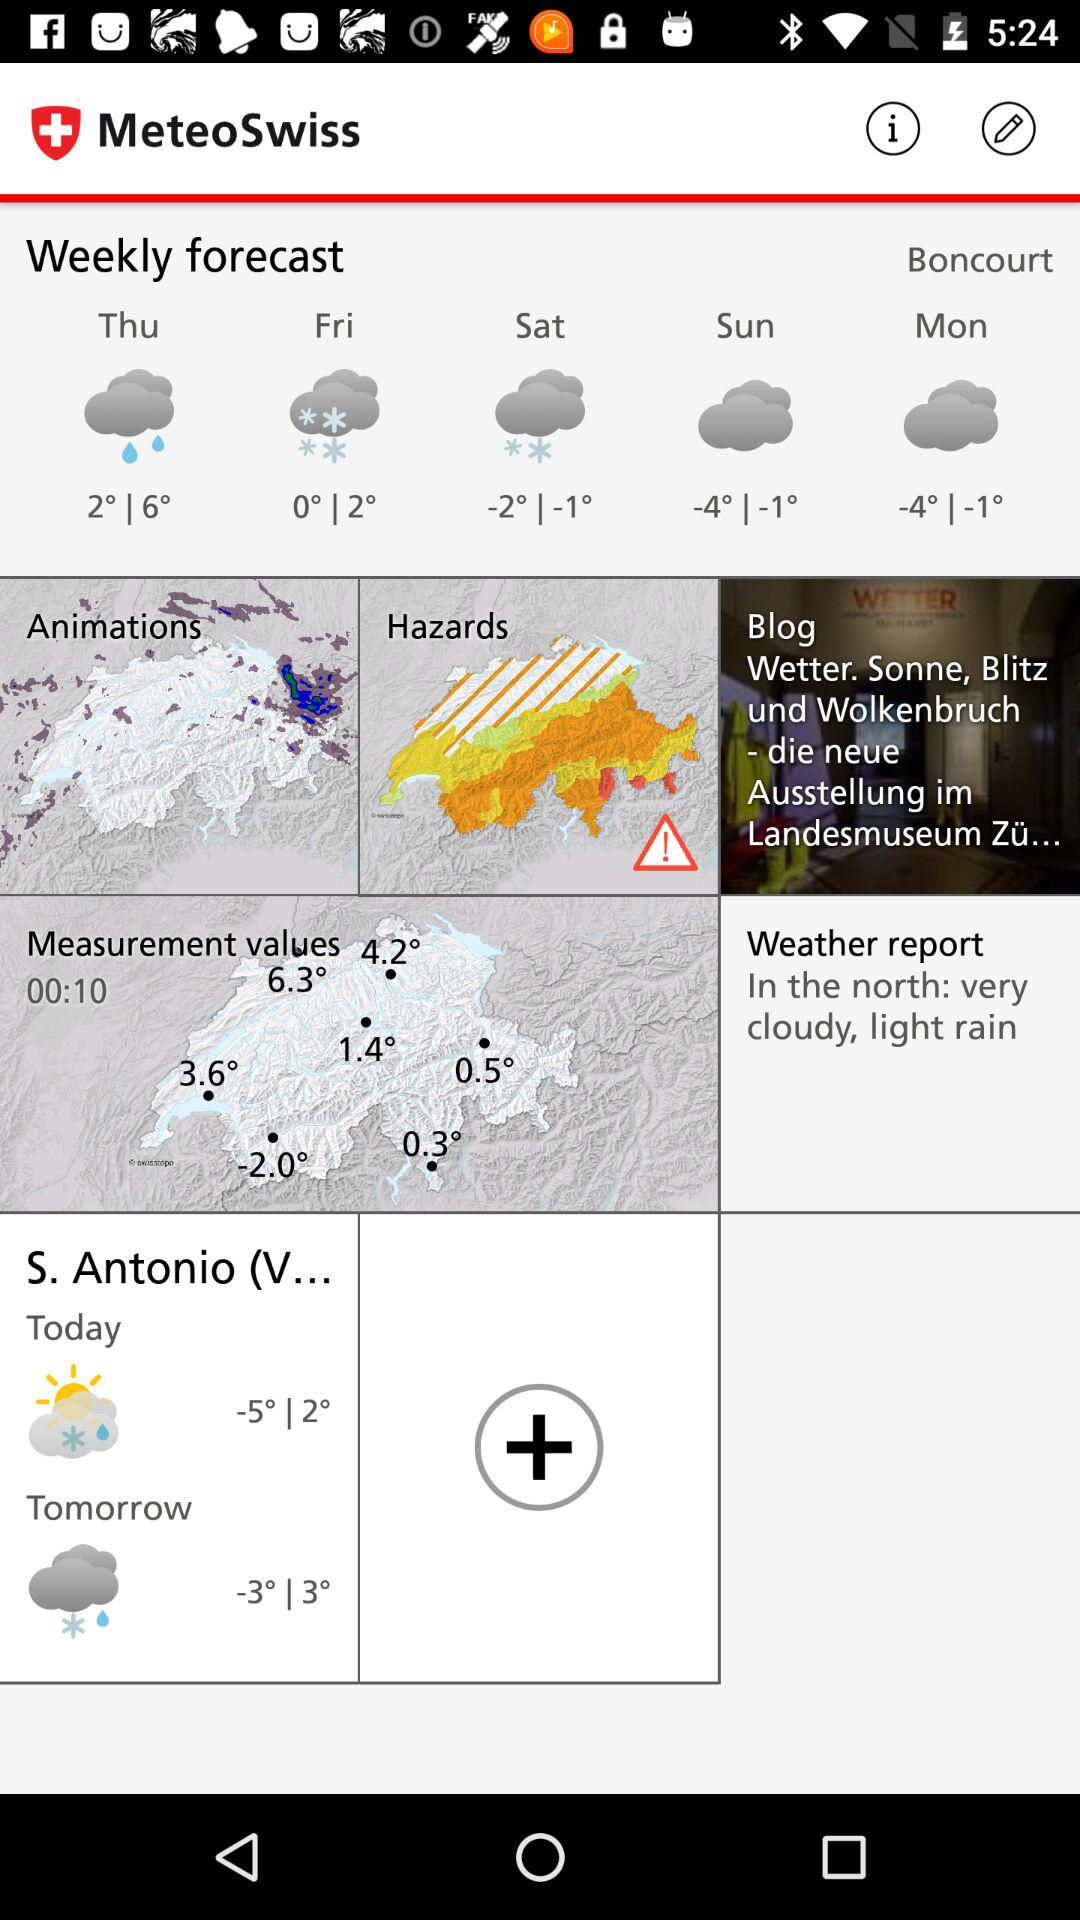What is the forecast for Thursday? The weather is rainy and the temperature ranges from 2° to 6°. 